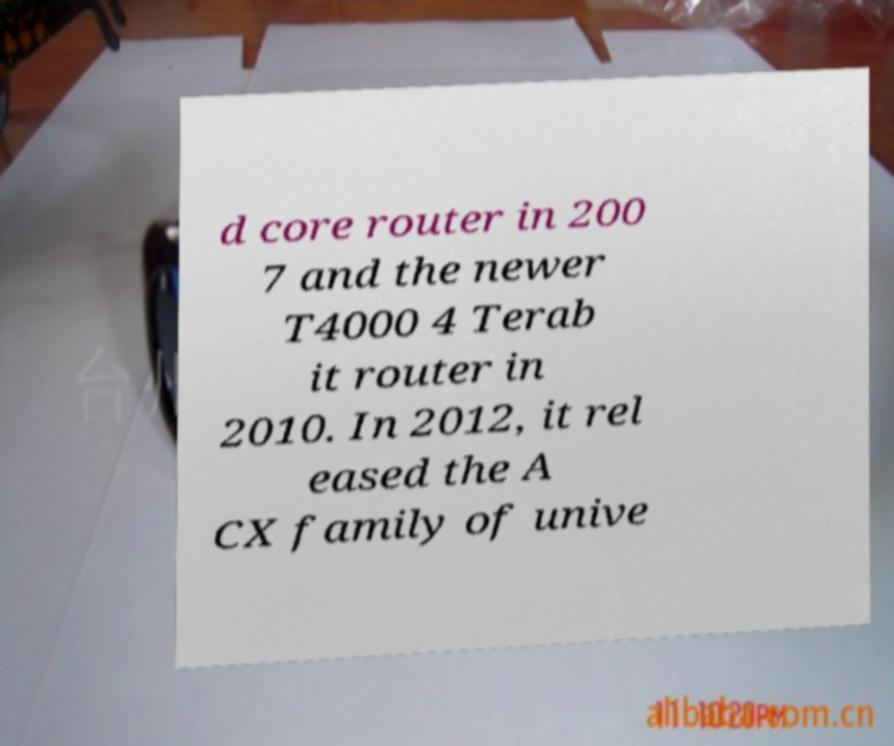Can you accurately transcribe the text from the provided image for me? d core router in 200 7 and the newer T4000 4 Terab it router in 2010. In 2012, it rel eased the A CX family of unive 